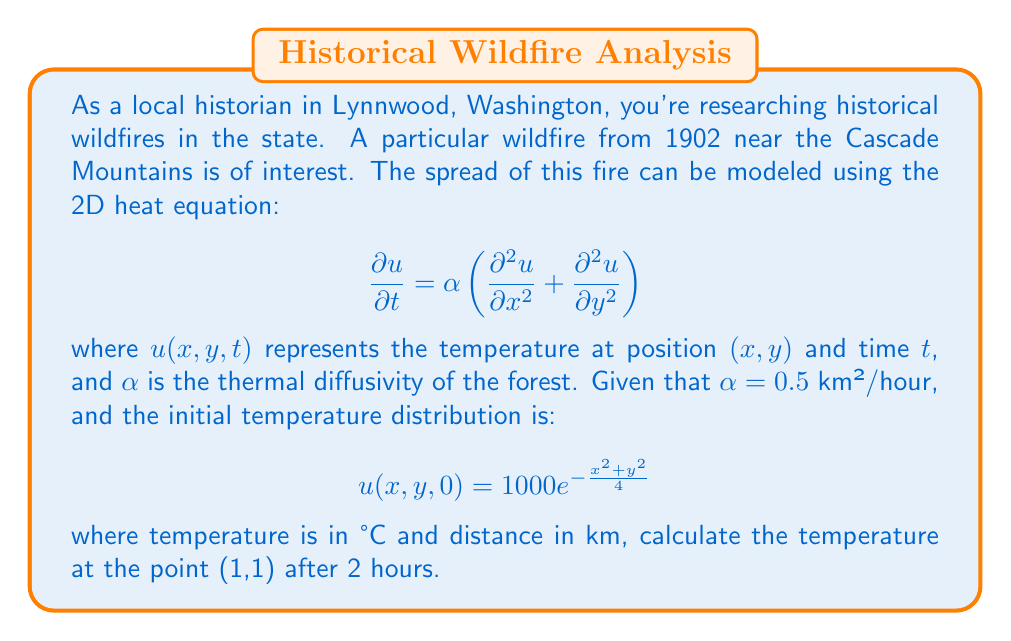Teach me how to tackle this problem. To solve this problem, we need to use the solution to the 2D heat equation with an initial Gaussian distribution. The solution is given by:

$$u(x,y,t) = \frac{1000}{1+\alpha t} \exp\left(-\frac{x^2+y^2}{4(1+\alpha t)}\right)$$

Let's break down the solution step-by-step:

1) We're given $\alpha = 0.5$ km²/hour

2) We need to find $u(1,1,2)$, so:
   $x = 1$, $y = 1$, and $t = 2$

3) Let's substitute these values into our solution:

   $$u(1,1,2) = \frac{1000}{1+0.5(2)} \exp\left(-\frac{1^2+1^2}{4(1+0.5(2))}\right)$$

4) Simplify the denominator in the fraction:
   
   $$u(1,1,2) = \frac{1000}{2} \exp\left(-\frac{2}{4(2)}\right)$$

5) Simplify further:

   $$u(1,1,2) = 500 \exp\left(-\frac{1}{4}\right)$$

6) Calculate the exponential:

   $$u(1,1,2) = 500 \cdot e^{-0.25} \approx 500 \cdot 0.7788$$

7) Multiply:

   $$u(1,1,2) \approx 389.4$$

Therefore, the temperature at the point (1,1) after 2 hours is approximately 389.4°C.
Answer: 389.4°C 